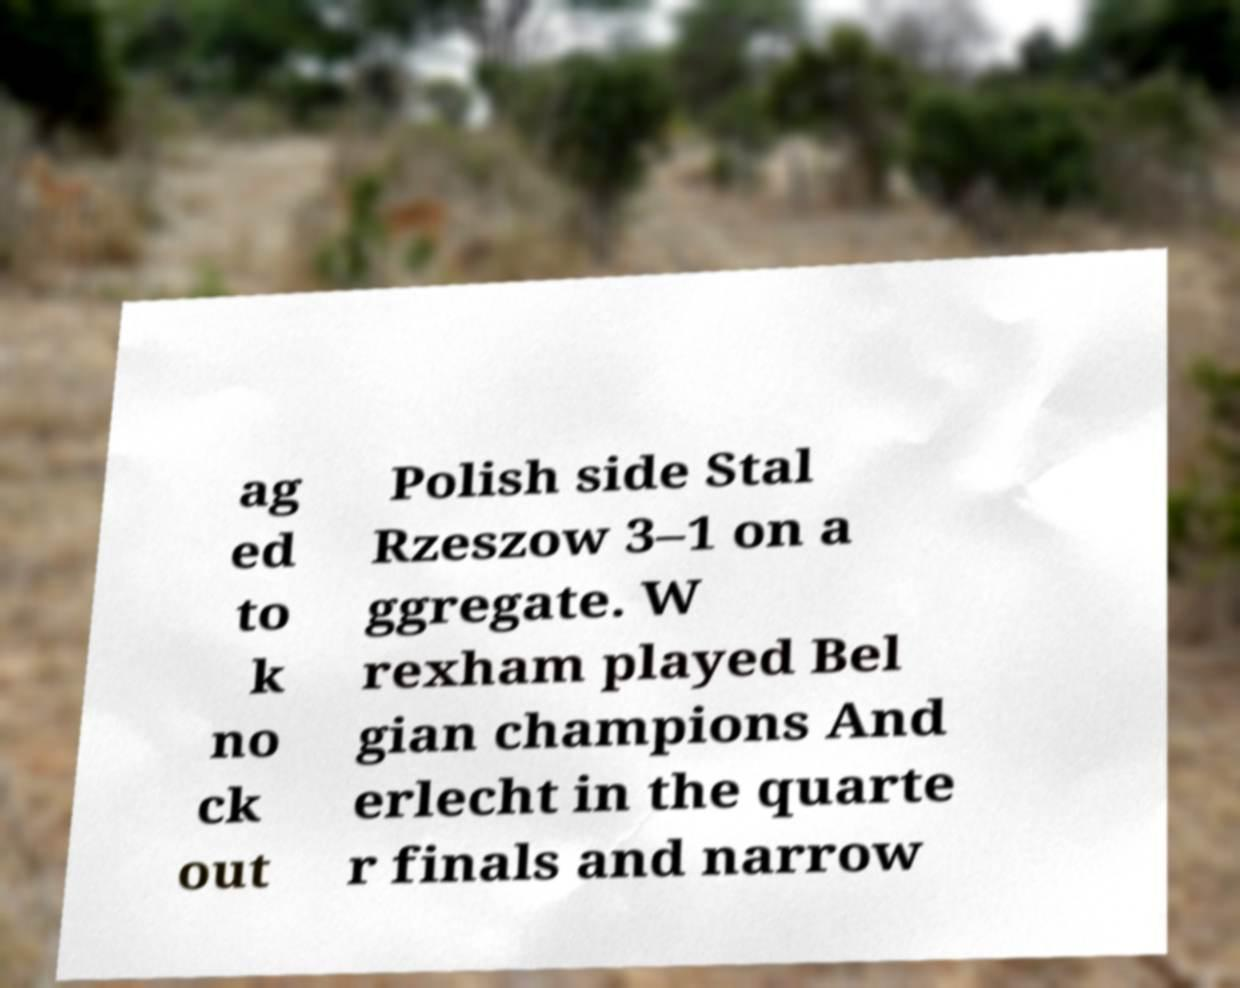What messages or text are displayed in this image? I need them in a readable, typed format. ag ed to k no ck out Polish side Stal Rzeszow 3–1 on a ggregate. W rexham played Bel gian champions And erlecht in the quarte r finals and narrow 